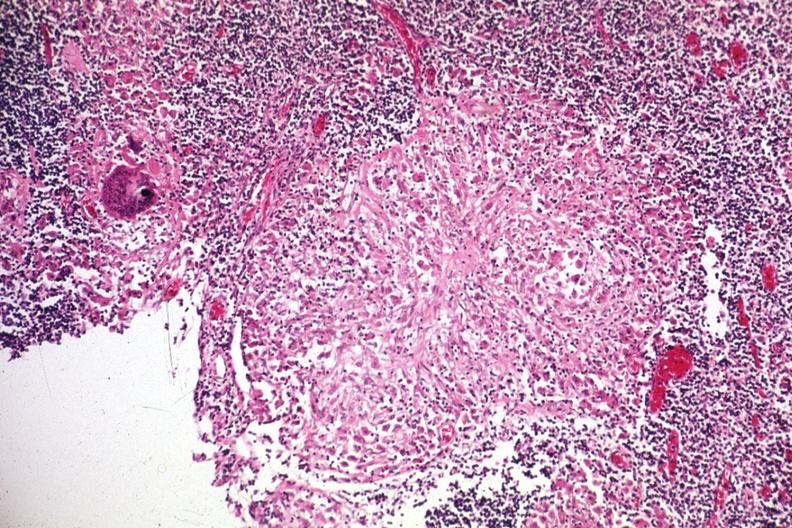what is present?
Answer the question using a single word or phrase. Lymph node 